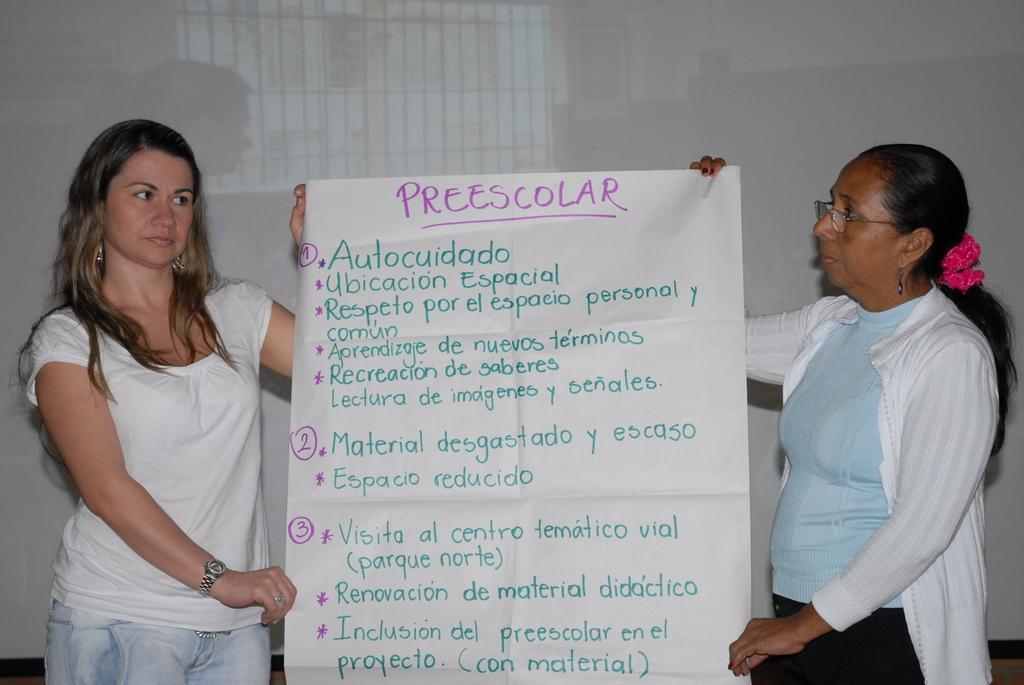Could you give a brief overview of what you see in this image? There are two women standing and holding a chart with their hands. I can see the letters written on the chart. This looks like a whiteboard. 